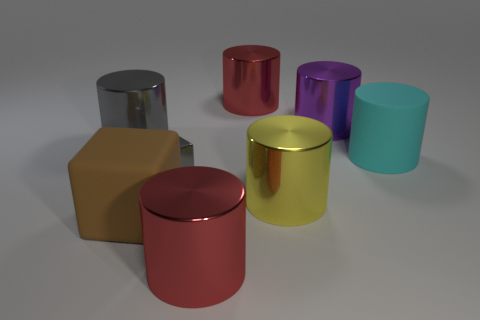What is the material of the gray cylinder?
Your answer should be compact. Metal. Are any purple shiny objects visible?
Your response must be concise. Yes. What color is the big rubber thing that is in front of the big cyan rubber cylinder?
Your response must be concise. Brown. There is a large red thing that is on the right side of the large thing that is in front of the brown thing; what number of tiny gray shiny cubes are to the right of it?
Provide a succinct answer. 0. What is the object that is to the left of the gray cube and in front of the cyan rubber object made of?
Make the answer very short. Rubber. Is the big yellow cylinder made of the same material as the red cylinder behind the brown thing?
Offer a very short reply. Yes. Are there more metal objects behind the large cyan cylinder than cylinders on the left side of the large brown thing?
Give a very brief answer. Yes. What is the shape of the large gray metallic thing?
Your answer should be compact. Cylinder. Is the material of the large cube that is to the left of the yellow thing the same as the big red object in front of the large brown thing?
Offer a terse response. No. There is a large purple shiny object that is on the right side of the large yellow cylinder; what is its shape?
Provide a short and direct response. Cylinder. 